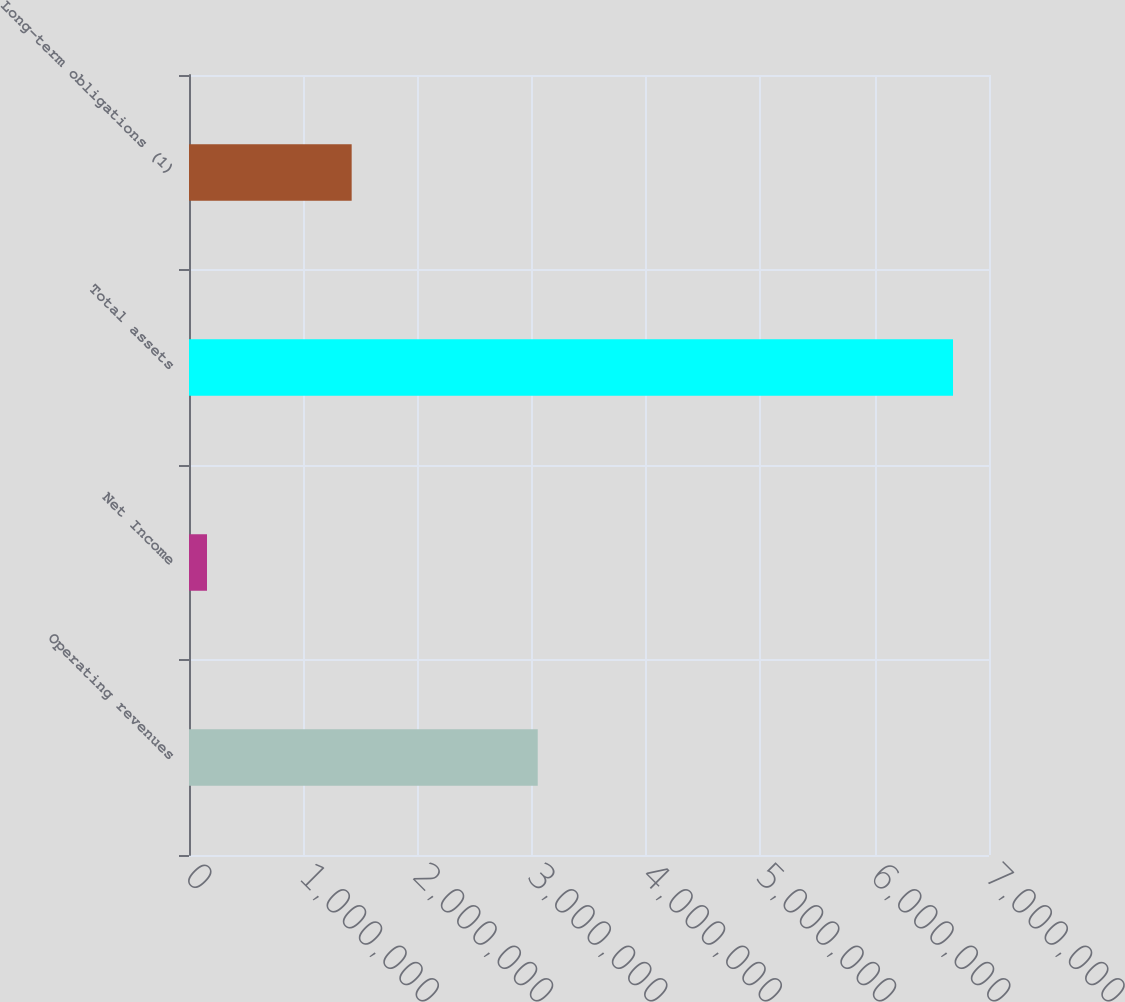Convert chart to OTSL. <chart><loc_0><loc_0><loc_500><loc_500><bar_chart><fcel>Operating revenues<fcel>Net Income<fcel>Total assets<fcel>Long-term obligations (1)<nl><fcel>3.05129e+06<fcel>157543<fcel>6.68517e+06<fcel>1.42332e+06<nl></chart> 